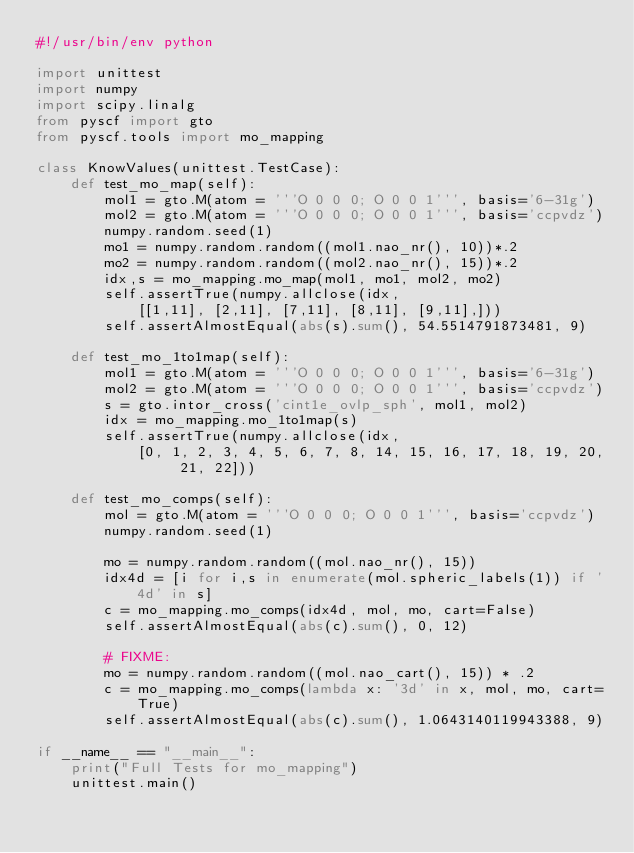<code> <loc_0><loc_0><loc_500><loc_500><_Python_>#!/usr/bin/env python

import unittest
import numpy
import scipy.linalg
from pyscf import gto
from pyscf.tools import mo_mapping

class KnowValues(unittest.TestCase):
    def test_mo_map(self):
        mol1 = gto.M(atom = '''O 0 0 0; O 0 0 1''', basis='6-31g')
        mol2 = gto.M(atom = '''O 0 0 0; O 0 0 1''', basis='ccpvdz')
        numpy.random.seed(1)
        mo1 = numpy.random.random((mol1.nao_nr(), 10))*.2
        mo2 = numpy.random.random((mol2.nao_nr(), 15))*.2
        idx,s = mo_mapping.mo_map(mol1, mo1, mol2, mo2)
        self.assertTrue(numpy.allclose(idx,
            [[1,11], [2,11], [7,11], [8,11], [9,11],]))
        self.assertAlmostEqual(abs(s).sum(), 54.5514791873481, 9)

    def test_mo_1to1map(self):
        mol1 = gto.M(atom = '''O 0 0 0; O 0 0 1''', basis='6-31g')
        mol2 = gto.M(atom = '''O 0 0 0; O 0 0 1''', basis='ccpvdz')
        s = gto.intor_cross('cint1e_ovlp_sph', mol1, mol2)
        idx = mo_mapping.mo_1to1map(s)
        self.assertTrue(numpy.allclose(idx,
            [0, 1, 2, 3, 4, 5, 6, 7, 8, 14, 15, 16, 17, 18, 19, 20, 21, 22]))

    def test_mo_comps(self):
        mol = gto.M(atom = '''O 0 0 0; O 0 0 1''', basis='ccpvdz')
        numpy.random.seed(1)

        mo = numpy.random.random((mol.nao_nr(), 15))
        idx4d = [i for i,s in enumerate(mol.spheric_labels(1)) if '4d' in s]
        c = mo_mapping.mo_comps(idx4d, mol, mo, cart=False)
        self.assertAlmostEqual(abs(c).sum(), 0, 12)

        # FIXME:
        mo = numpy.random.random((mol.nao_cart(), 15)) * .2
        c = mo_mapping.mo_comps(lambda x: '3d' in x, mol, mo, cart=True)
        self.assertAlmostEqual(abs(c).sum(), 1.0643140119943388, 9)

if __name__ == "__main__":
    print("Full Tests for mo_mapping")
    unittest.main()


</code> 